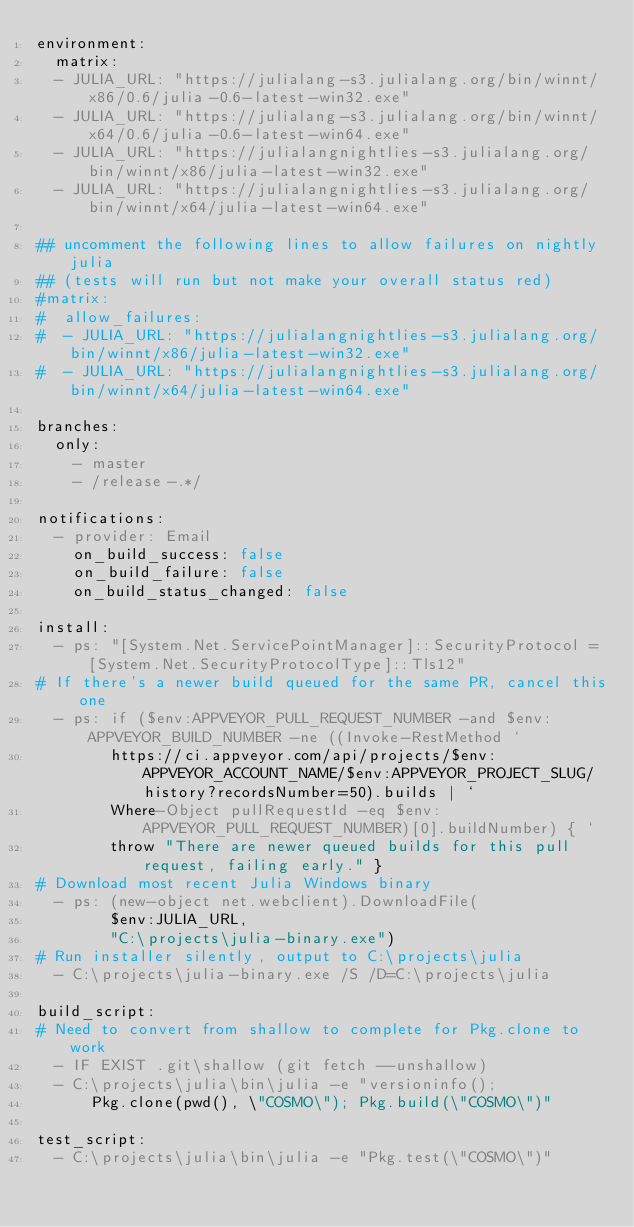Convert code to text. <code><loc_0><loc_0><loc_500><loc_500><_YAML_>environment:
  matrix:
  - JULIA_URL: "https://julialang-s3.julialang.org/bin/winnt/x86/0.6/julia-0.6-latest-win32.exe"
  - JULIA_URL: "https://julialang-s3.julialang.org/bin/winnt/x64/0.6/julia-0.6-latest-win64.exe"
  - JULIA_URL: "https://julialangnightlies-s3.julialang.org/bin/winnt/x86/julia-latest-win32.exe"
  - JULIA_URL: "https://julialangnightlies-s3.julialang.org/bin/winnt/x64/julia-latest-win64.exe"

## uncomment the following lines to allow failures on nightly julia
## (tests will run but not make your overall status red)
#matrix:
#  allow_failures:
#  - JULIA_URL: "https://julialangnightlies-s3.julialang.org/bin/winnt/x86/julia-latest-win32.exe"
#  - JULIA_URL: "https://julialangnightlies-s3.julialang.org/bin/winnt/x64/julia-latest-win64.exe"

branches:
  only:
    - master
    - /release-.*/

notifications:
  - provider: Email
    on_build_success: false
    on_build_failure: false
    on_build_status_changed: false

install:
  - ps: "[System.Net.ServicePointManager]::SecurityProtocol = [System.Net.SecurityProtocolType]::Tls12"
# If there's a newer build queued for the same PR, cancel this one
  - ps: if ($env:APPVEYOR_PULL_REQUEST_NUMBER -and $env:APPVEYOR_BUILD_NUMBER -ne ((Invoke-RestMethod `
        https://ci.appveyor.com/api/projects/$env:APPVEYOR_ACCOUNT_NAME/$env:APPVEYOR_PROJECT_SLUG/history?recordsNumber=50).builds | `
        Where-Object pullRequestId -eq $env:APPVEYOR_PULL_REQUEST_NUMBER)[0].buildNumber) { `
        throw "There are newer queued builds for this pull request, failing early." }
# Download most recent Julia Windows binary
  - ps: (new-object net.webclient).DownloadFile(
        $env:JULIA_URL,
        "C:\projects\julia-binary.exe")
# Run installer silently, output to C:\projects\julia
  - C:\projects\julia-binary.exe /S /D=C:\projects\julia

build_script:
# Need to convert from shallow to complete for Pkg.clone to work
  - IF EXIST .git\shallow (git fetch --unshallow)
  - C:\projects\julia\bin\julia -e "versioninfo();
      Pkg.clone(pwd(), \"COSMO\"); Pkg.build(\"COSMO\")"

test_script:
  - C:\projects\julia\bin\julia -e "Pkg.test(\"COSMO\")"
</code> 